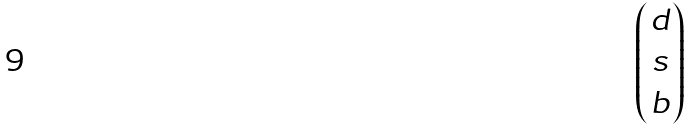<formula> <loc_0><loc_0><loc_500><loc_500>\begin{pmatrix} d \\ s \\ b \end{pmatrix}</formula> 